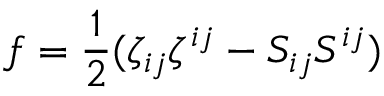<formula> <loc_0><loc_0><loc_500><loc_500>f = \frac { 1 } { 2 } ( \zeta _ { i j } \zeta ^ { i j } - S _ { i j } S ^ { i j } )</formula> 